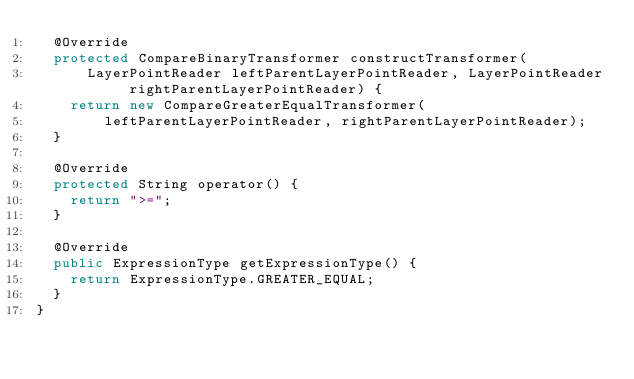<code> <loc_0><loc_0><loc_500><loc_500><_Java_>  @Override
  protected CompareBinaryTransformer constructTransformer(
      LayerPointReader leftParentLayerPointReader, LayerPointReader rightParentLayerPointReader) {
    return new CompareGreaterEqualTransformer(
        leftParentLayerPointReader, rightParentLayerPointReader);
  }

  @Override
  protected String operator() {
    return ">=";
  }

  @Override
  public ExpressionType getExpressionType() {
    return ExpressionType.GREATER_EQUAL;
  }
}
</code> 